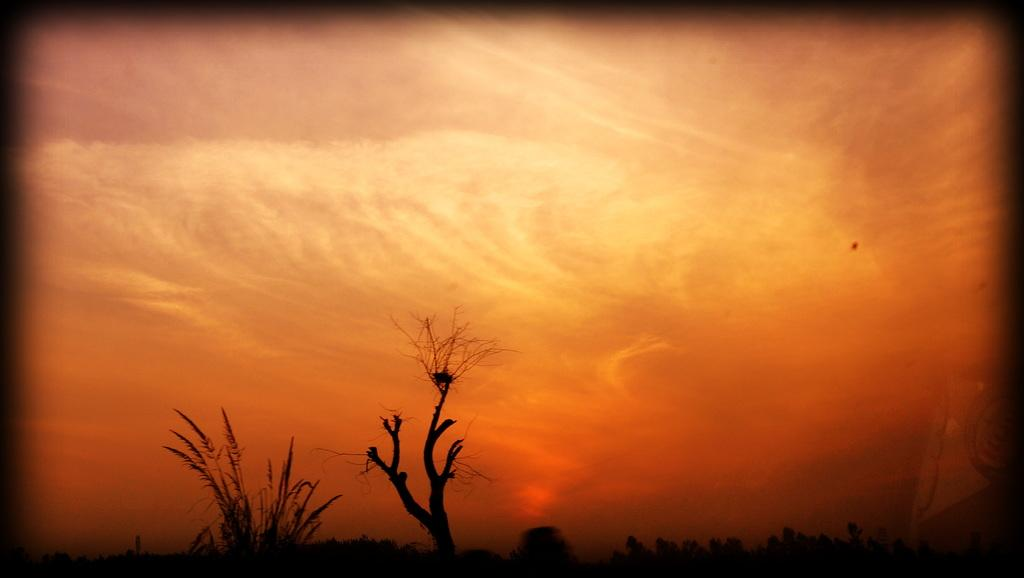What type of tree is at the bottom of the image? There is a bare tree at the bottom of the image. What type of vegetation is present in the image besides the tree? There is grass and other plants in the image. What can be seen in the sky in the background of the image? There are clouds in the sky in the background of the image. How has the image been modified? The image has been edited with a frame. What advice does the aunt give to the plants in the image? There is no aunt present in the image, so no advice can be given. What type of curve can be seen in the image? There is no curve present in the image; it features a bare tree, grass, plants, clouds, and a framed border. 